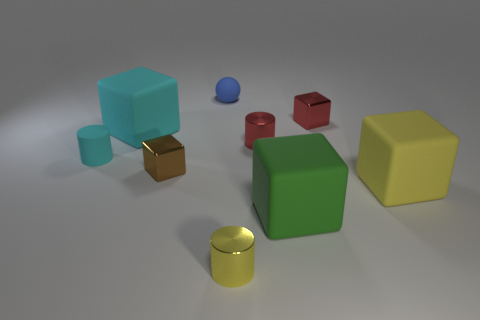What number of brown cubes are made of the same material as the tiny yellow cylinder?
Your answer should be very brief. 1. How many other objects are the same size as the yellow cylinder?
Offer a terse response. 5. Is there a blue matte thing of the same size as the red shiny cube?
Your answer should be compact. Yes. Does the big object that is behind the matte cylinder have the same color as the matte cylinder?
Provide a short and direct response. Yes. How many objects are either gray metallic spheres or tiny yellow metal cylinders?
Provide a succinct answer. 1. Does the green matte object behind the yellow cylinder have the same size as the cyan rubber cylinder?
Offer a terse response. No. What size is the block that is behind the red cylinder and to the left of the tiny yellow object?
Your response must be concise. Large. How many other objects are the same shape as the small yellow metal object?
Offer a terse response. 2. What number of other objects are the same material as the tiny red cube?
Ensure brevity in your answer.  3. There is a cyan thing that is the same shape as the big green thing; what is its size?
Offer a very short reply. Large. 